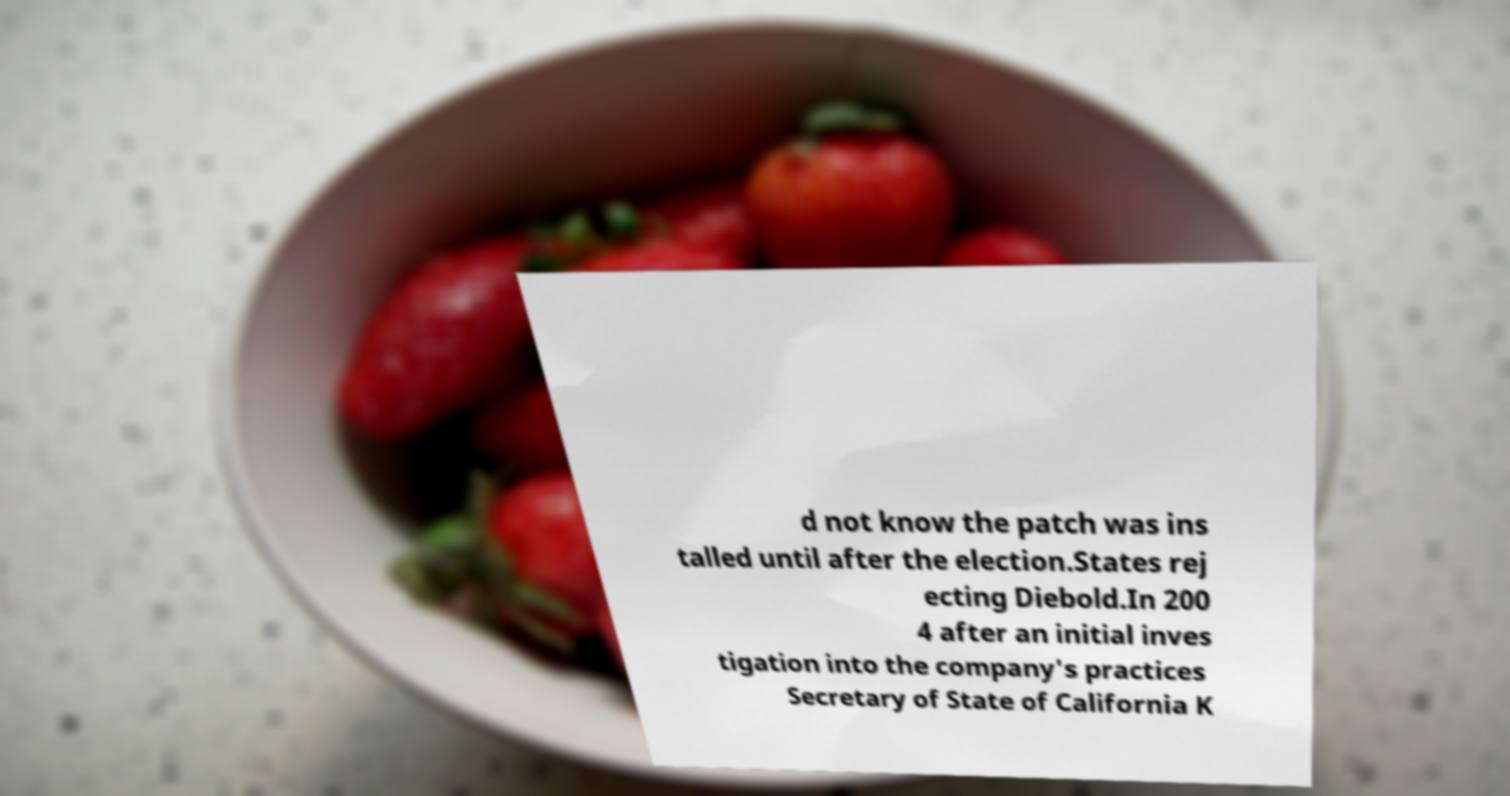There's text embedded in this image that I need extracted. Can you transcribe it verbatim? d not know the patch was ins talled until after the election.States rej ecting Diebold.In 200 4 after an initial inves tigation into the company's practices Secretary of State of California K 